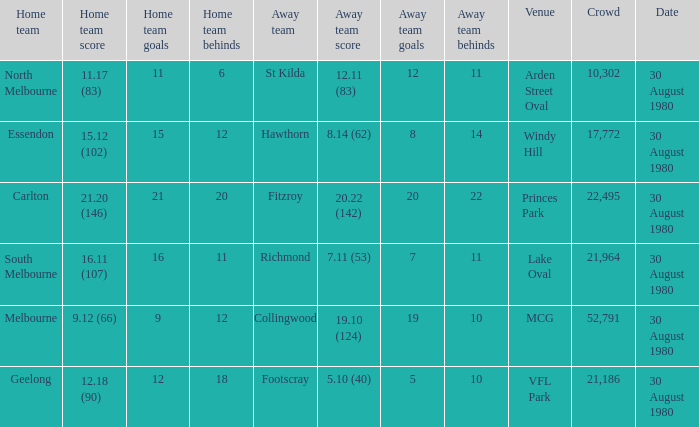What was the score for south melbourne at home? 16.11 (107). 